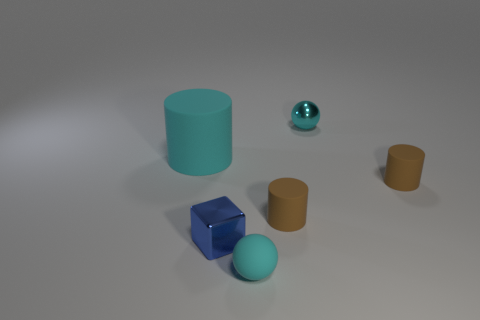What is the cyan ball that is behind the small cyan matte thing made of?
Your answer should be very brief. Metal. How many things are tiny blue cubes or rubber things that are in front of the blue block?
Provide a succinct answer. 2. There is a cyan shiny thing that is the same size as the blue shiny thing; what is its shape?
Your answer should be compact. Sphere. How many shiny things have the same color as the matte ball?
Give a very brief answer. 1. Is the brown object on the left side of the cyan metal ball made of the same material as the big cyan cylinder?
Keep it short and to the point. Yes. There is a small cyan metal object; what shape is it?
Provide a short and direct response. Sphere. How many blue things are either metallic spheres or small metal blocks?
Make the answer very short. 1. How many other things are there of the same material as the large cylinder?
Your response must be concise. 3. Do the small cyan thing in front of the block and the tiny cyan metallic object have the same shape?
Your response must be concise. Yes. Are any large blue things visible?
Offer a very short reply. No. 